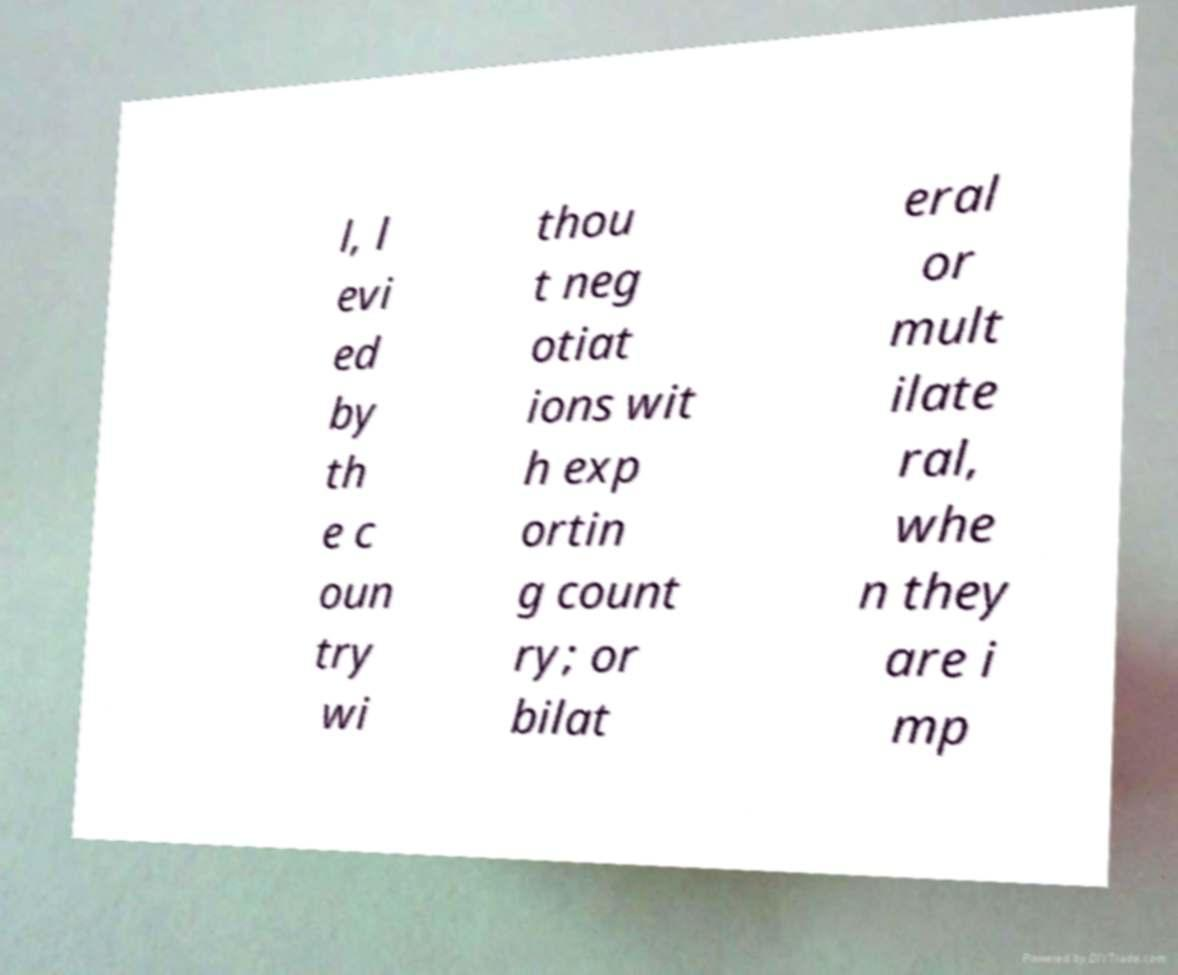Could you extract and type out the text from this image? l, l evi ed by th e c oun try wi thou t neg otiat ions wit h exp ortin g count ry; or bilat eral or mult ilate ral, whe n they are i mp 